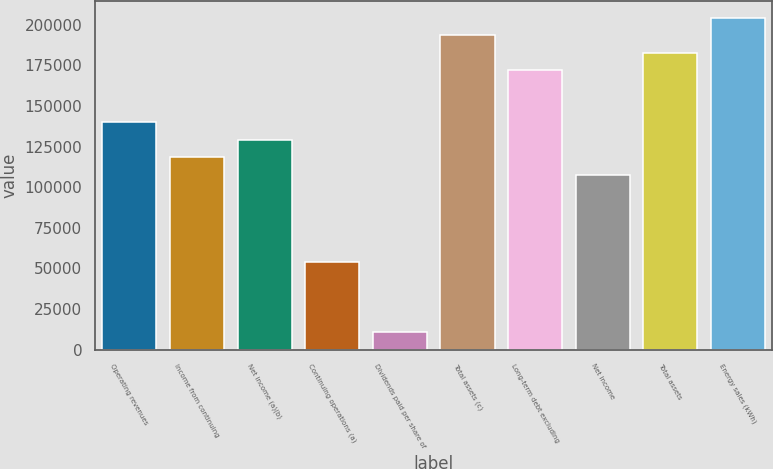Convert chart. <chart><loc_0><loc_0><loc_500><loc_500><bar_chart><fcel>Operating revenues<fcel>Income from continuing<fcel>Net income (a)(b)<fcel>Continuing operations (a)<fcel>Dividends paid per share of<fcel>Total assets (c)<fcel>Long-term debt excluding<fcel>Net income<fcel>Total assets<fcel>Energy sales (kWh)<nl><fcel>139935<fcel>118407<fcel>129171<fcel>53822.7<fcel>10766.4<fcel>193756<fcel>172227<fcel>107643<fcel>182991<fcel>204520<nl></chart> 